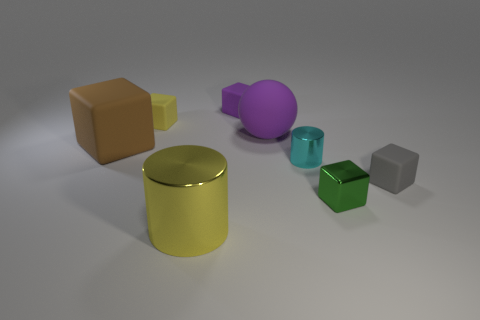Subtract all yellow matte blocks. How many blocks are left? 4 Subtract all purple blocks. How many blocks are left? 4 Subtract all blue cubes. Subtract all green balls. How many cubes are left? 5 Add 1 tiny rubber cubes. How many objects exist? 9 Subtract all balls. How many objects are left? 7 Add 5 purple cubes. How many purple cubes exist? 6 Subtract 0 cyan balls. How many objects are left? 8 Subtract all big gray metal cylinders. Subtract all yellow matte things. How many objects are left? 7 Add 7 shiny cylinders. How many shiny cylinders are left? 9 